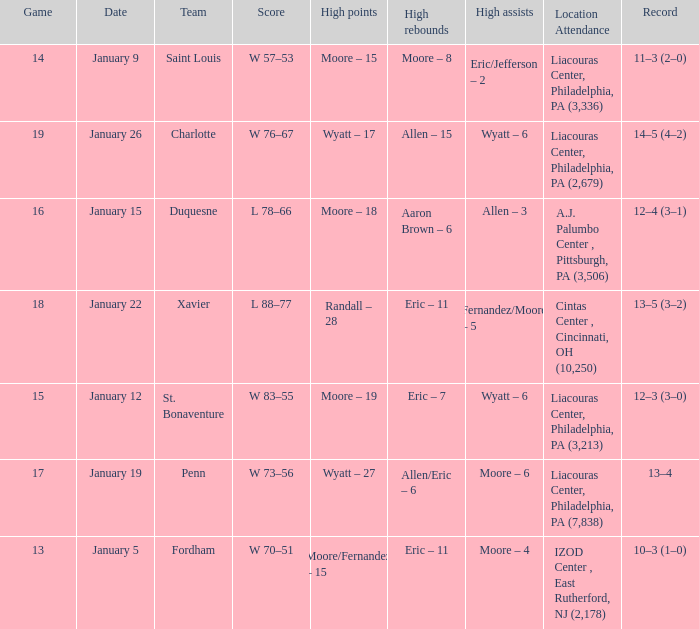Who had the most assists and how many did they have on January 5? Moore – 4. 